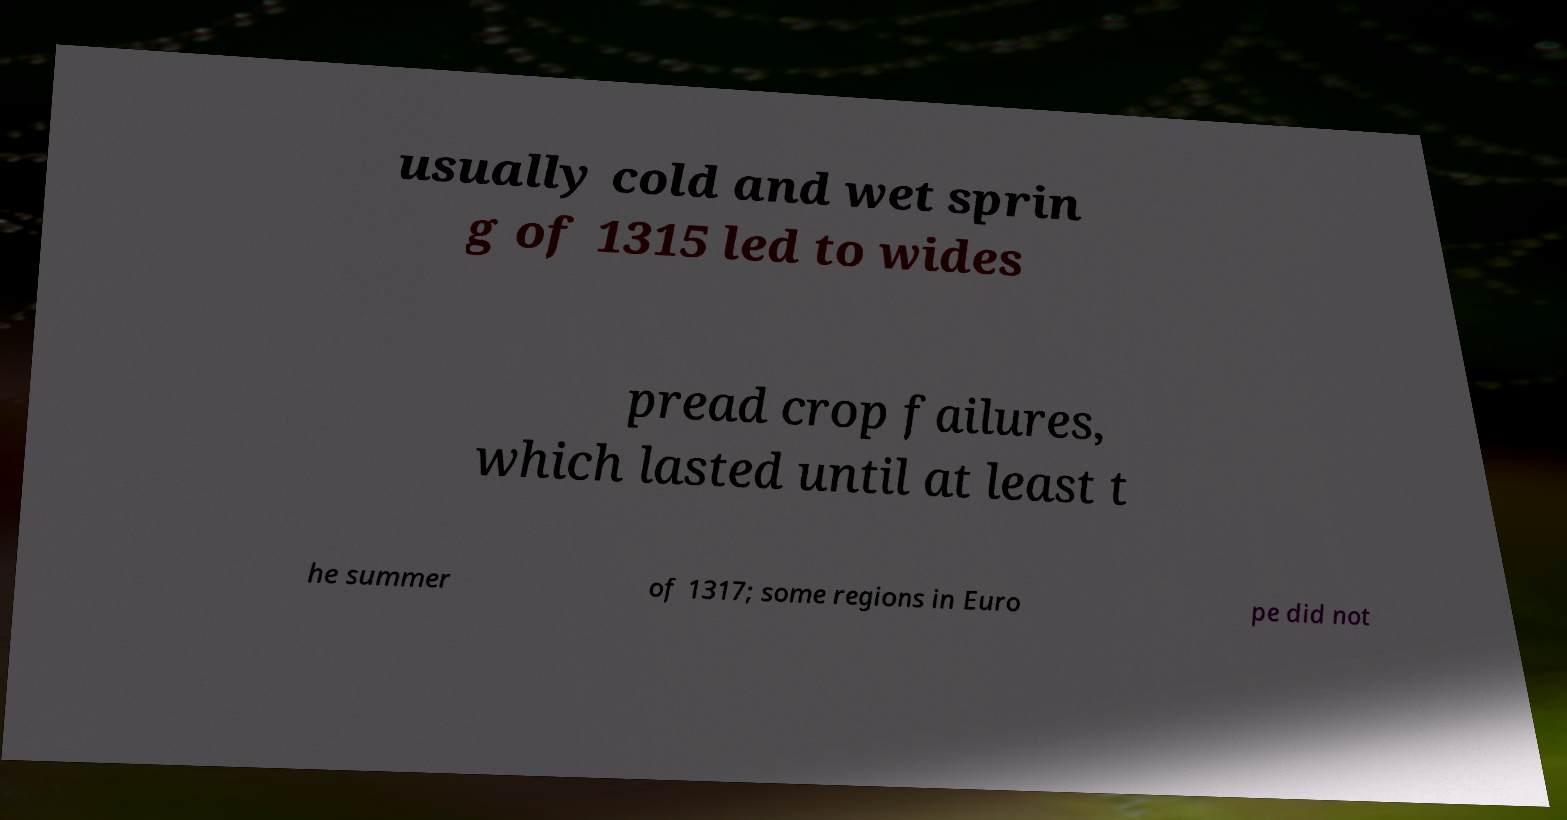Please read and relay the text visible in this image. What does it say? usually cold and wet sprin g of 1315 led to wides pread crop failures, which lasted until at least t he summer of 1317; some regions in Euro pe did not 